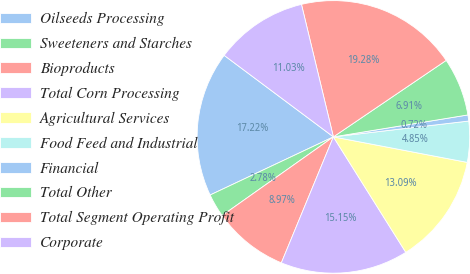<chart> <loc_0><loc_0><loc_500><loc_500><pie_chart><fcel>Oilseeds Processing<fcel>Sweeteners and Starches<fcel>Bioproducts<fcel>Total Corn Processing<fcel>Agricultural Services<fcel>Food Feed and Industrial<fcel>Financial<fcel>Total Other<fcel>Total Segment Operating Profit<fcel>Corporate<nl><fcel>17.22%<fcel>2.78%<fcel>8.97%<fcel>15.15%<fcel>13.09%<fcel>4.85%<fcel>0.72%<fcel>6.91%<fcel>19.28%<fcel>11.03%<nl></chart> 